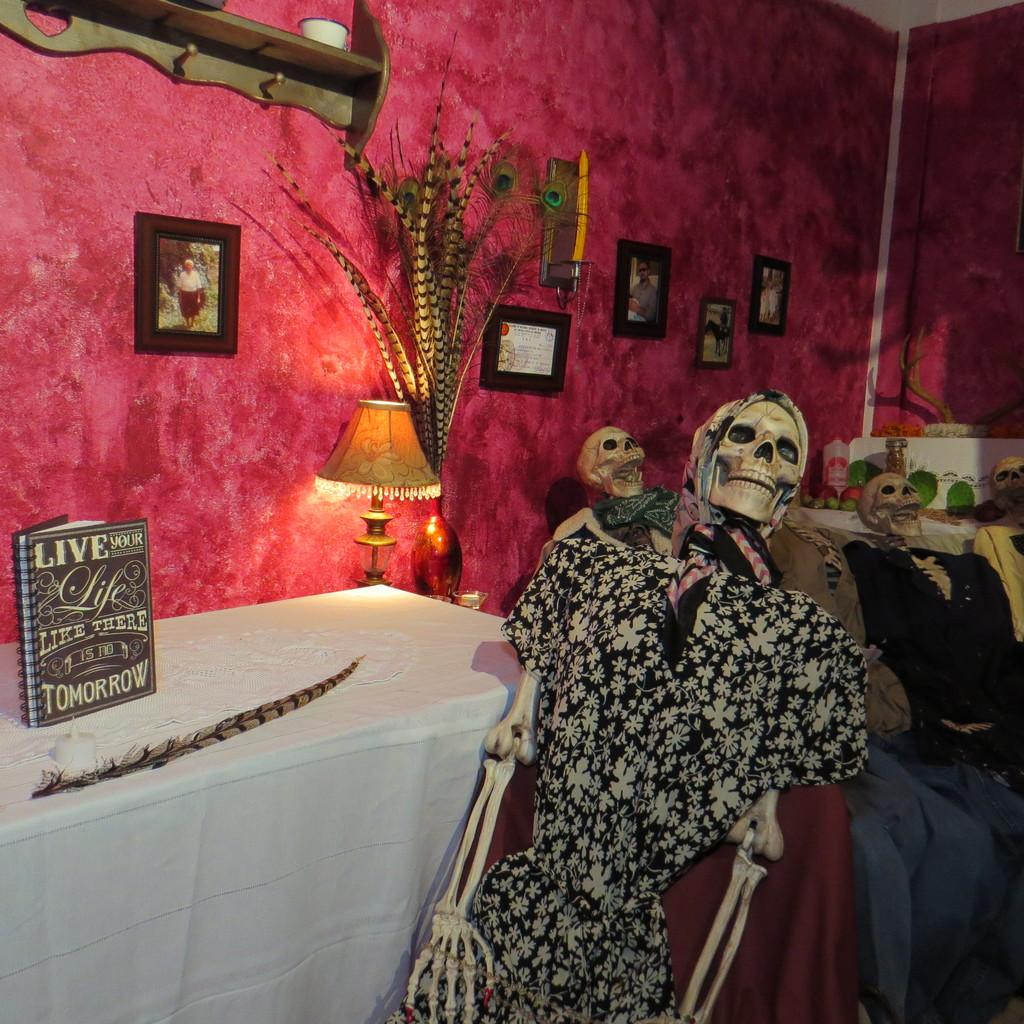What can be seen in the image that resembles human bodies? There are many skeletons dressed up with clothes in the image. What object can be seen on a table in the image? There is a book on a table in the image. What type of decorations are on the wall in the image? There are photo frames on the wall in the image. What type of seat can be seen in the image? There is no seat present in the image. 